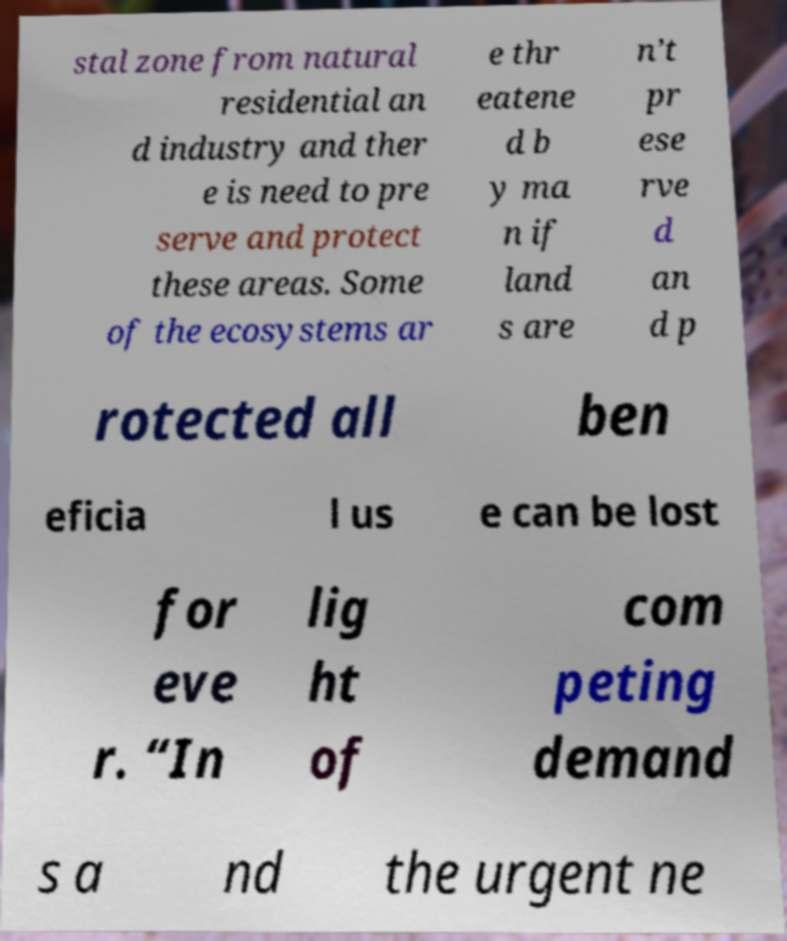Can you read and provide the text displayed in the image?This photo seems to have some interesting text. Can you extract and type it out for me? stal zone from natural residential an d industry and ther e is need to pre serve and protect these areas. Some of the ecosystems ar e thr eatene d b y ma n if land s are n’t pr ese rve d an d p rotected all ben eficia l us e can be lost for eve r. “In lig ht of com peting demand s a nd the urgent ne 